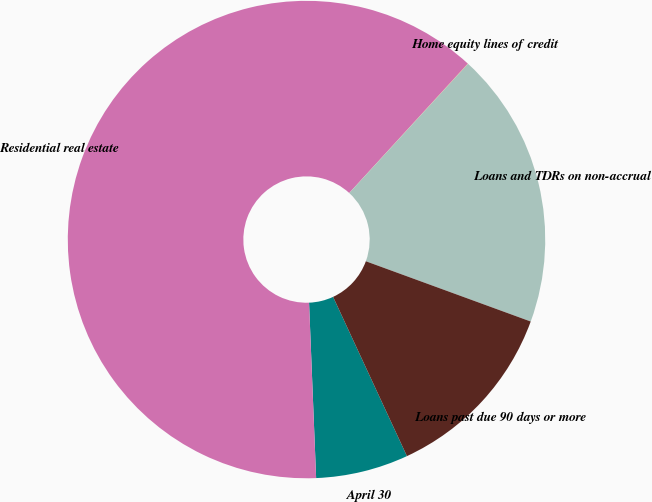Convert chart to OTSL. <chart><loc_0><loc_0><loc_500><loc_500><pie_chart><fcel>April 30<fcel>Residential real estate<fcel>Home equity lines of credit<fcel>Loans and TDRs on non-accrual<fcel>Loans past due 90 days or more<nl><fcel>6.27%<fcel>62.45%<fcel>0.02%<fcel>18.75%<fcel>12.51%<nl></chart> 